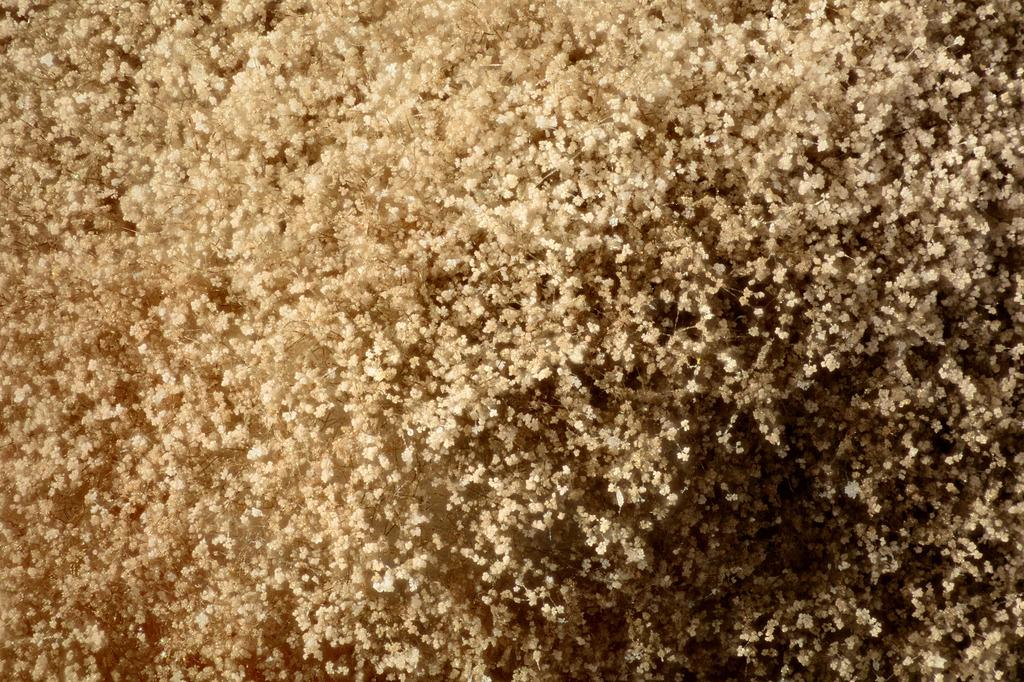What type of flora is present in the image? There are tiny flowers in the image. Are the flowers part of a larger plant or tree? The flowers are likely associated with trees. What type of van can be seen driving through the vein in the image? There is no van or vein present in the image; it features tiny flowers likely associated with trees. 